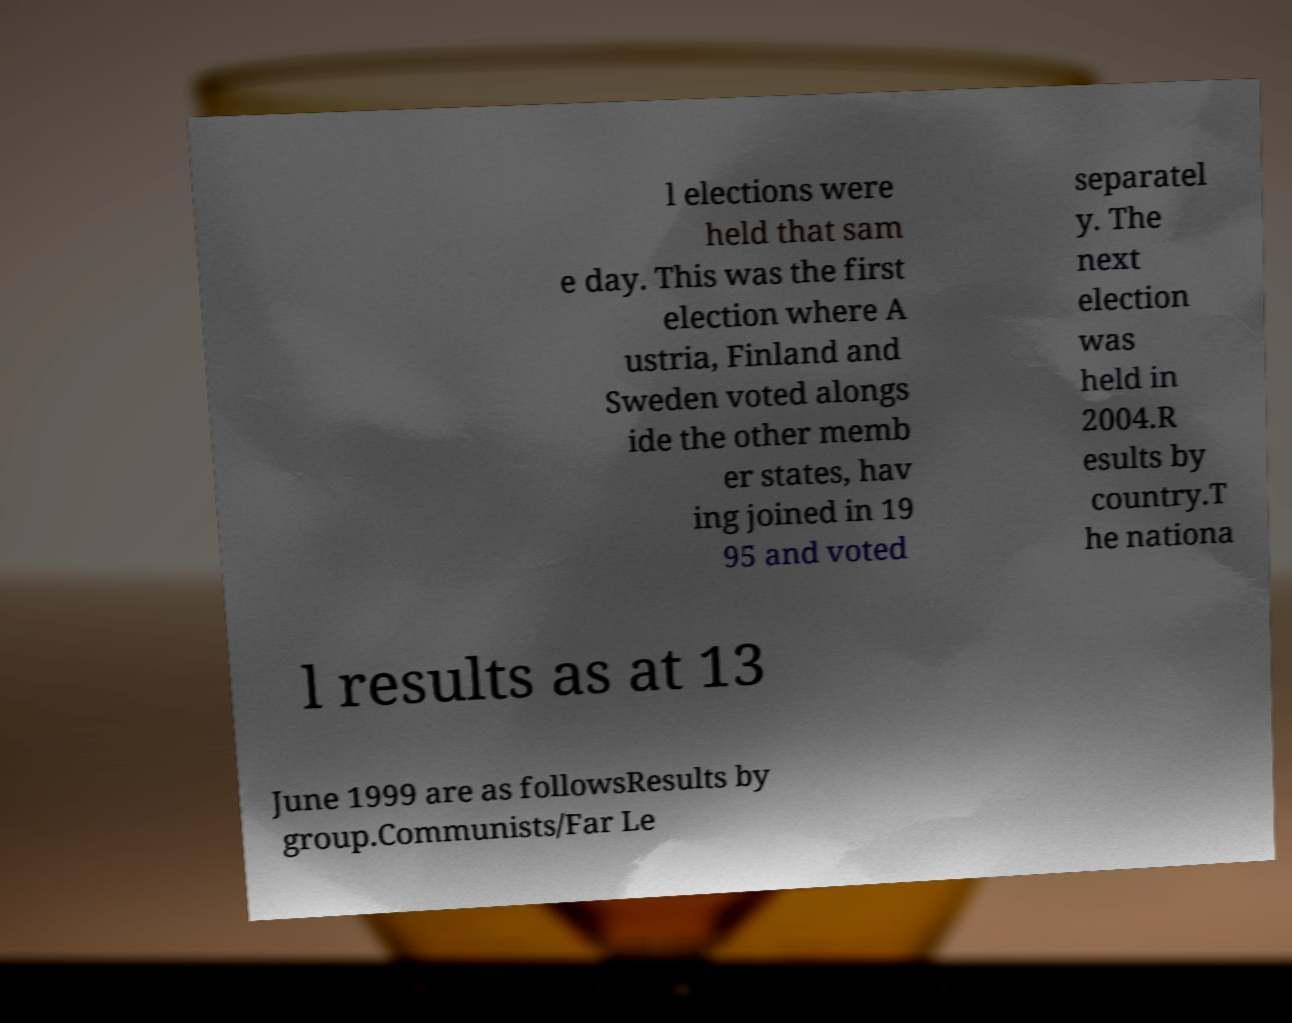There's text embedded in this image that I need extracted. Can you transcribe it verbatim? l elections were held that sam e day. This was the first election where A ustria, Finland and Sweden voted alongs ide the other memb er states, hav ing joined in 19 95 and voted separatel y. The next election was held in 2004.R esults by country.T he nationa l results as at 13 June 1999 are as followsResults by group.Communists/Far Le 